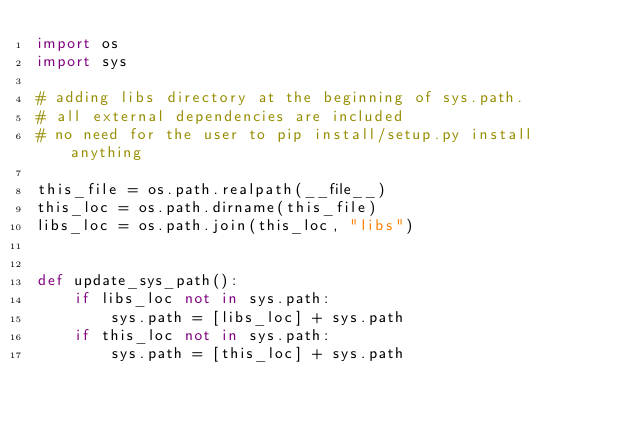<code> <loc_0><loc_0><loc_500><loc_500><_Python_>import os
import sys

# adding libs directory at the beginning of sys.path.
# all external dependencies are included
# no need for the user to pip install/setup.py install anything

this_file = os.path.realpath(__file__)
this_loc = os.path.dirname(this_file)
libs_loc = os.path.join(this_loc, "libs")


def update_sys_path():
    if libs_loc not in sys.path:
        sys.path = [libs_loc] + sys.path
    if this_loc not in sys.path:
        sys.path = [this_loc] + sys.path
</code> 